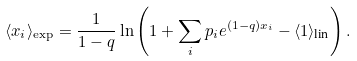<formula> <loc_0><loc_0><loc_500><loc_500>\langle x _ { i } \rangle _ { \exp } = \frac { 1 } { 1 - q } \ln \left ( 1 + \sum _ { i } p _ { i } e ^ { ( 1 - q ) x _ { i } } - \langle 1 \rangle _ { \text {lin} } \right ) .</formula> 